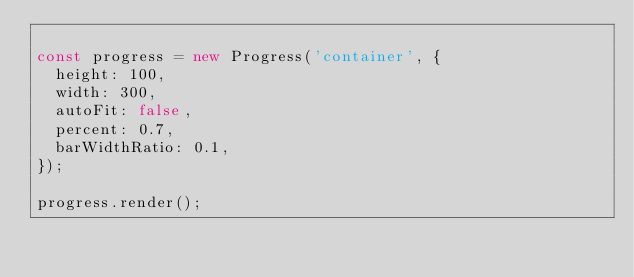Convert code to text. <code><loc_0><loc_0><loc_500><loc_500><_TypeScript_>
const progress = new Progress('container', {
  height: 100,
  width: 300,
  autoFit: false,
  percent: 0.7,
  barWidthRatio: 0.1,
});

progress.render();
</code> 